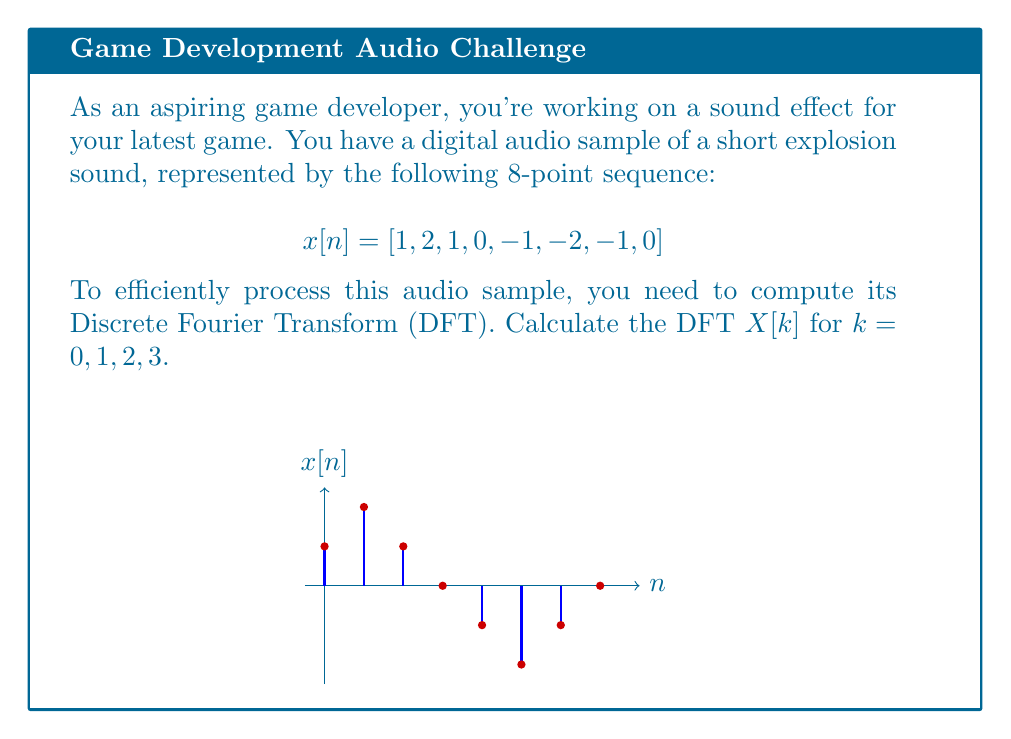What is the answer to this math problem? Let's approach this step-by-step:

1) The DFT formula for an N-point sequence is:

   $$X[k] = \sum_{n=0}^{N-1} x[n] e^{-j2\pi kn/N}$$

   Where $N = 8$ in our case.

2) We need to calculate $X[k]$ for $k = 0, 1, 2, 3$. Let's start with $k = 0$:

   $$X[0] = \sum_{n=0}^{7} x[n] e^{-j2\pi 0n/8} = \sum_{n=0}^{7} x[n] = 1 + 2 + 1 + 0 + (-1) + (-2) + (-1) + 0 = 0$$

3) For $k = 1$:

   $$X[1] = \sum_{n=0}^{7} x[n] e^{-j2\pi n/8}$$
   
   $$= 1 + 2e^{-j\pi/4} + e^{-j\pi/2} + 0 + (-1)e^{-j\pi} + (-2)e^{-j5\pi/4} + (-1)e^{-j3\pi/2} + 0$$
   
   $$= 1 + 2(\frac{\sqrt{2}}{2} - j\frac{\sqrt{2}}{2}) + (0 - j) + (-1) + (-2)(-\frac{\sqrt{2}}{2} - j\frac{\sqrt{2}}{2}) + (0 + j)$$
   
   $$= 1 + \sqrt{2} - j\sqrt{2} - j - 1 + \sqrt{2} + j\sqrt{2} + j = 2\sqrt{2}$$

4) For $k = 2$:

   $$X[2] = \sum_{n=0}^{7} x[n] e^{-j2\pi 2n/8} = \sum_{n=0}^{7} x[n] e^{-j\pi n/2}$$
   
   $$= 1 + 2e^{-j\pi/2} + e^{-j\pi} + 0 + (-1)e^{-j2\pi} + (-2)e^{-j5\pi/2} + (-1)e^{-j3\pi} + 0$$
   
   $$= 1 - 2j - 1 + 1 + 2j - 1 = 0$$

5) For $k = 3$:

   $$X[3] = \sum_{n=0}^{7} x[n] e^{-j2\pi 3n/8}$$
   
   $$= 1 + 2e^{-j3\pi/4} + e^{-j3\pi/2} + 0 + (-1)e^{-j9\pi/4} + (-2)e^{-j15\pi/4} + (-1)e^{-j21\pi/4} + 0$$
   
   $$= 1 + 2(-\frac{\sqrt{2}}{2} - j\frac{\sqrt{2}}{2}) + (0 + j) + (-1)(j) + (-2)(\frac{\sqrt{2}}{2} - j\frac{\sqrt{2}}{2}) + (-1)(-j)$$
   
   $$= 1 - \sqrt{2} - j\sqrt{2} + j - j + \sqrt{2} - j\sqrt{2} + j = 2 - 2j\sqrt{2}$$
Answer: $X[0] = 0$, $X[1] = 2\sqrt{2}$, $X[2] = 0$, $X[3] = 2 - 2j\sqrt{2}$ 